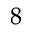Convert formula to latex. <formula><loc_0><loc_0><loc_500><loc_500>{ ^ { 8 } }</formula> 